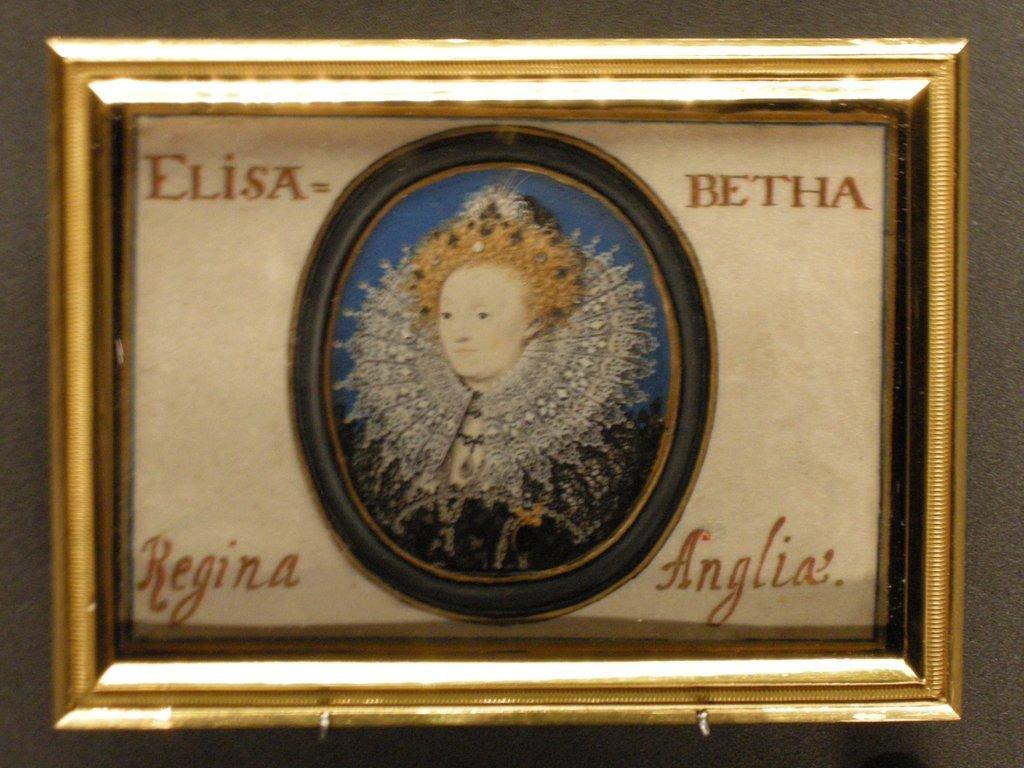<image>
Relay a brief, clear account of the picture shown. Four names are written on each edge of a portrait of a female. 